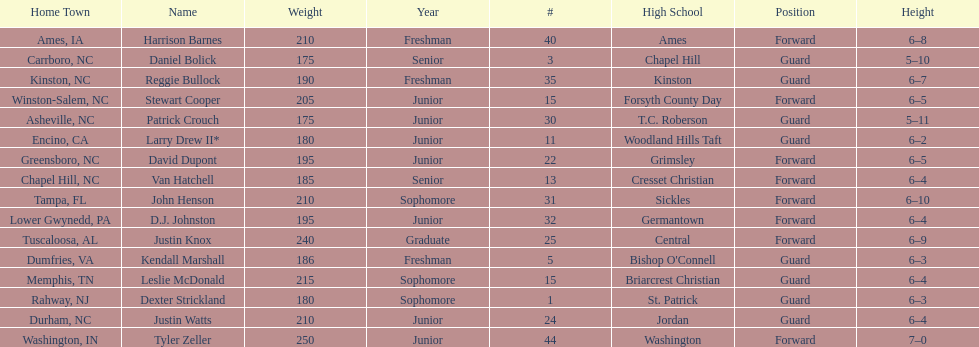Tallest player on the team Tyler Zeller. 